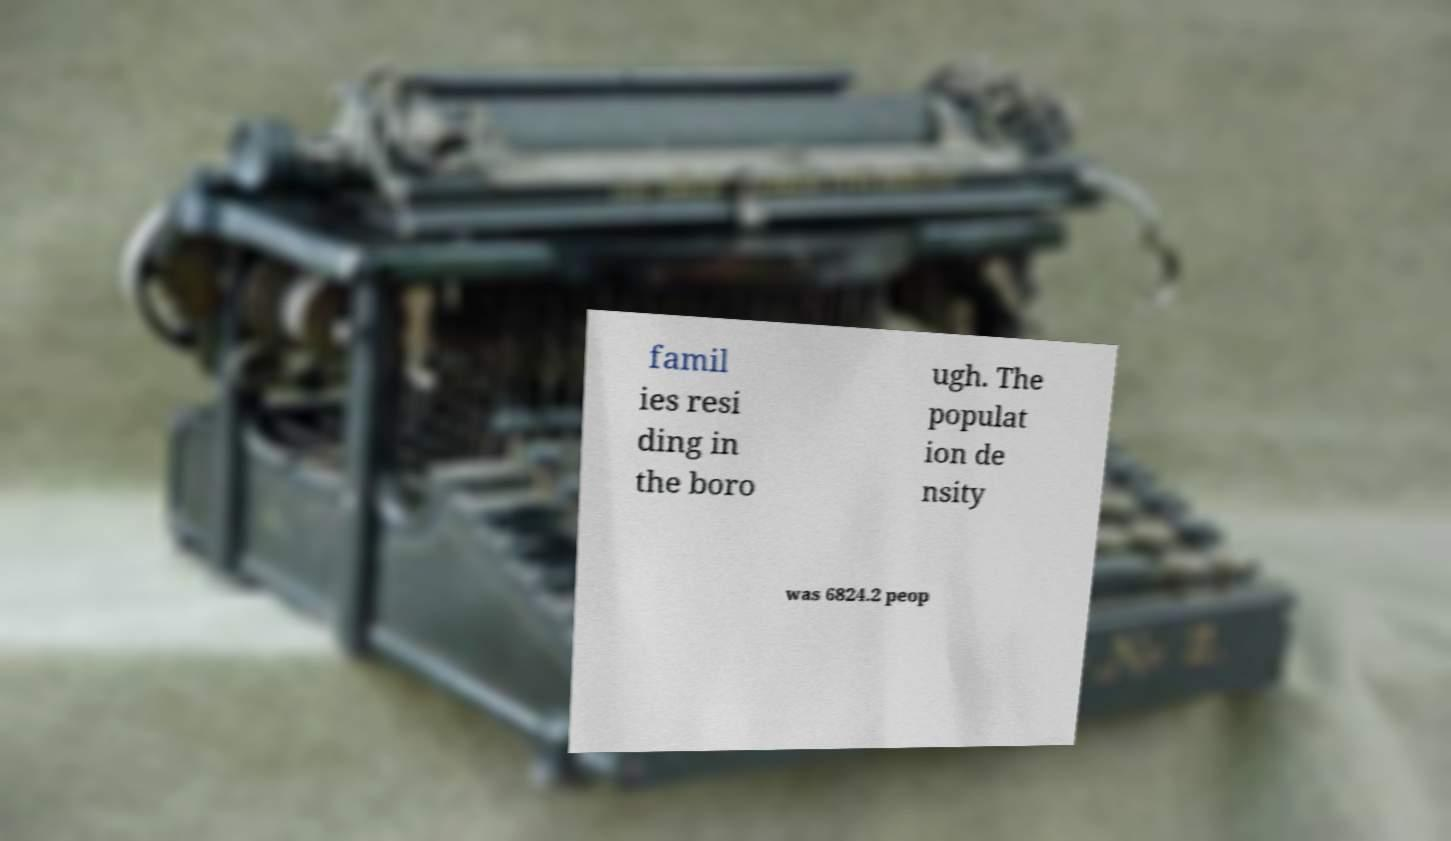What messages or text are displayed in this image? I need them in a readable, typed format. famil ies resi ding in the boro ugh. The populat ion de nsity was 6824.2 peop 